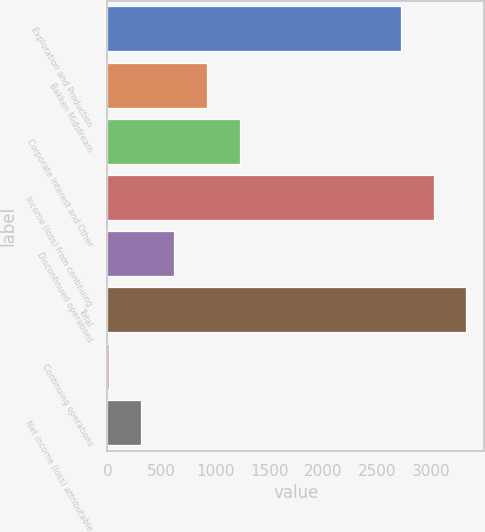<chart> <loc_0><loc_0><loc_500><loc_500><bar_chart><fcel>Exploration and Production<fcel>Bakken Midstream<fcel>Corporate Interest and Other<fcel>Income (loss) from continuing<fcel>Discontinued operations<fcel>Total<fcel>Continuing operations<fcel>Net income (loss) attributable<nl><fcel>2717<fcel>924.23<fcel>1228.77<fcel>3021.54<fcel>619.69<fcel>3326.08<fcel>10.61<fcel>315.15<nl></chart> 